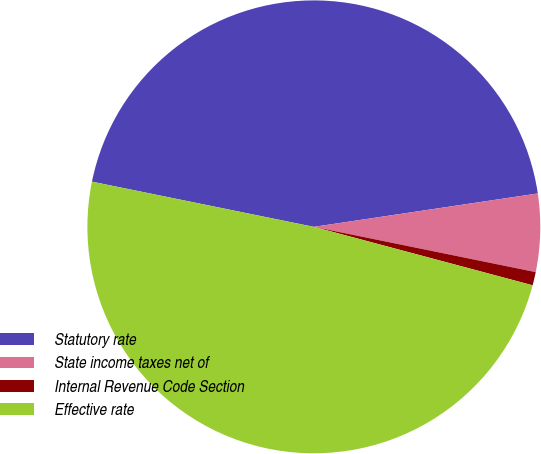<chart> <loc_0><loc_0><loc_500><loc_500><pie_chart><fcel>Statutory rate<fcel>State income taxes net of<fcel>Internal Revenue Code Section<fcel>Effective rate<nl><fcel>44.44%<fcel>5.56%<fcel>0.95%<fcel>49.04%<nl></chart> 